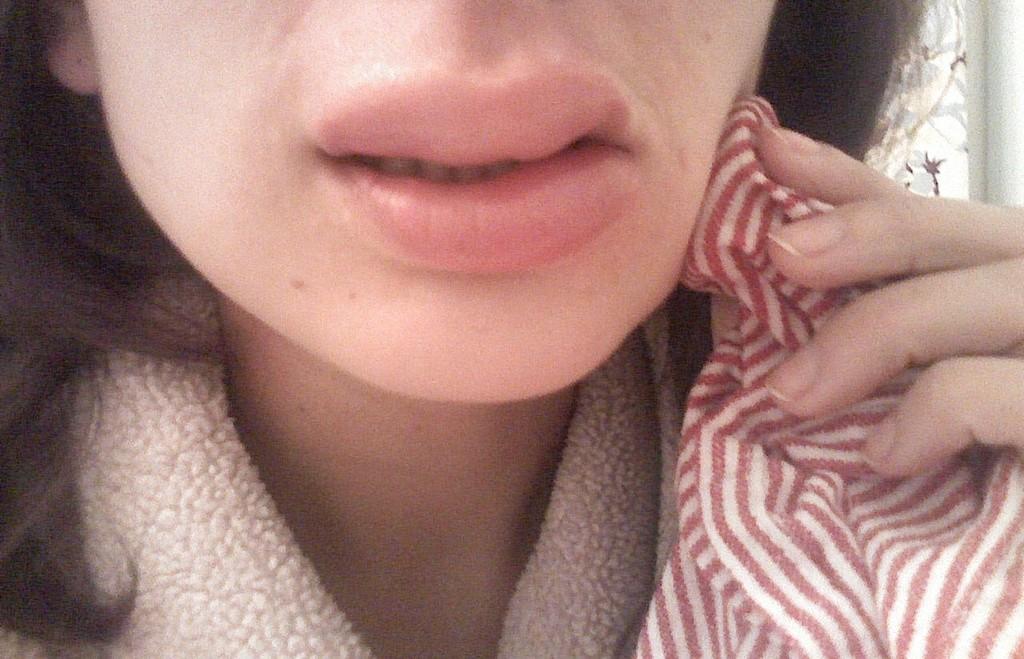Can you describe this image briefly? In the image I can see one girl lips and cloth. 